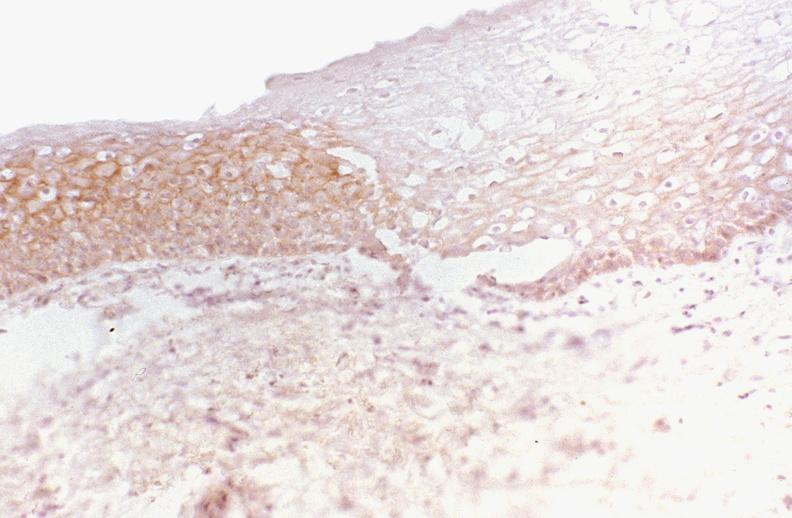where is this from?
Answer the question using a single word or phrase. Gastrointestinal system 